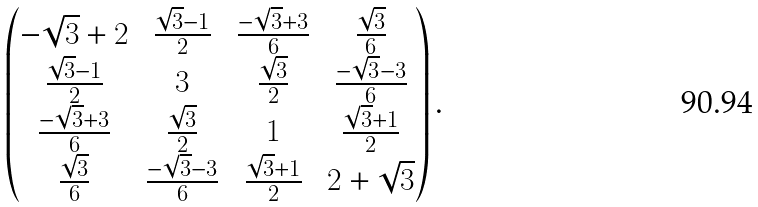Convert formula to latex. <formula><loc_0><loc_0><loc_500><loc_500>\begin{pmatrix} - \sqrt { 3 } + 2 & \frac { \sqrt { 3 } - 1 } { 2 } & \frac { - \sqrt { 3 } + 3 } { 6 } & \frac { \sqrt { 3 } } { 6 } \\ \frac { \sqrt { 3 } - 1 } { 2 } & 3 & \frac { \sqrt { 3 } } { 2 } & \frac { - \sqrt { 3 } - 3 } { 6 } \\ \frac { - \sqrt { 3 } + 3 } { 6 } & \frac { \sqrt { 3 } } { 2 } & 1 & \frac { \sqrt { 3 } + 1 } { 2 } \\ \frac { \sqrt { 3 } } { 6 } & \frac { - \sqrt { 3 } - 3 } { 6 } & \frac { \sqrt { 3 } + 1 } { 2 } & 2 + \sqrt { 3 } \end{pmatrix} .</formula> 